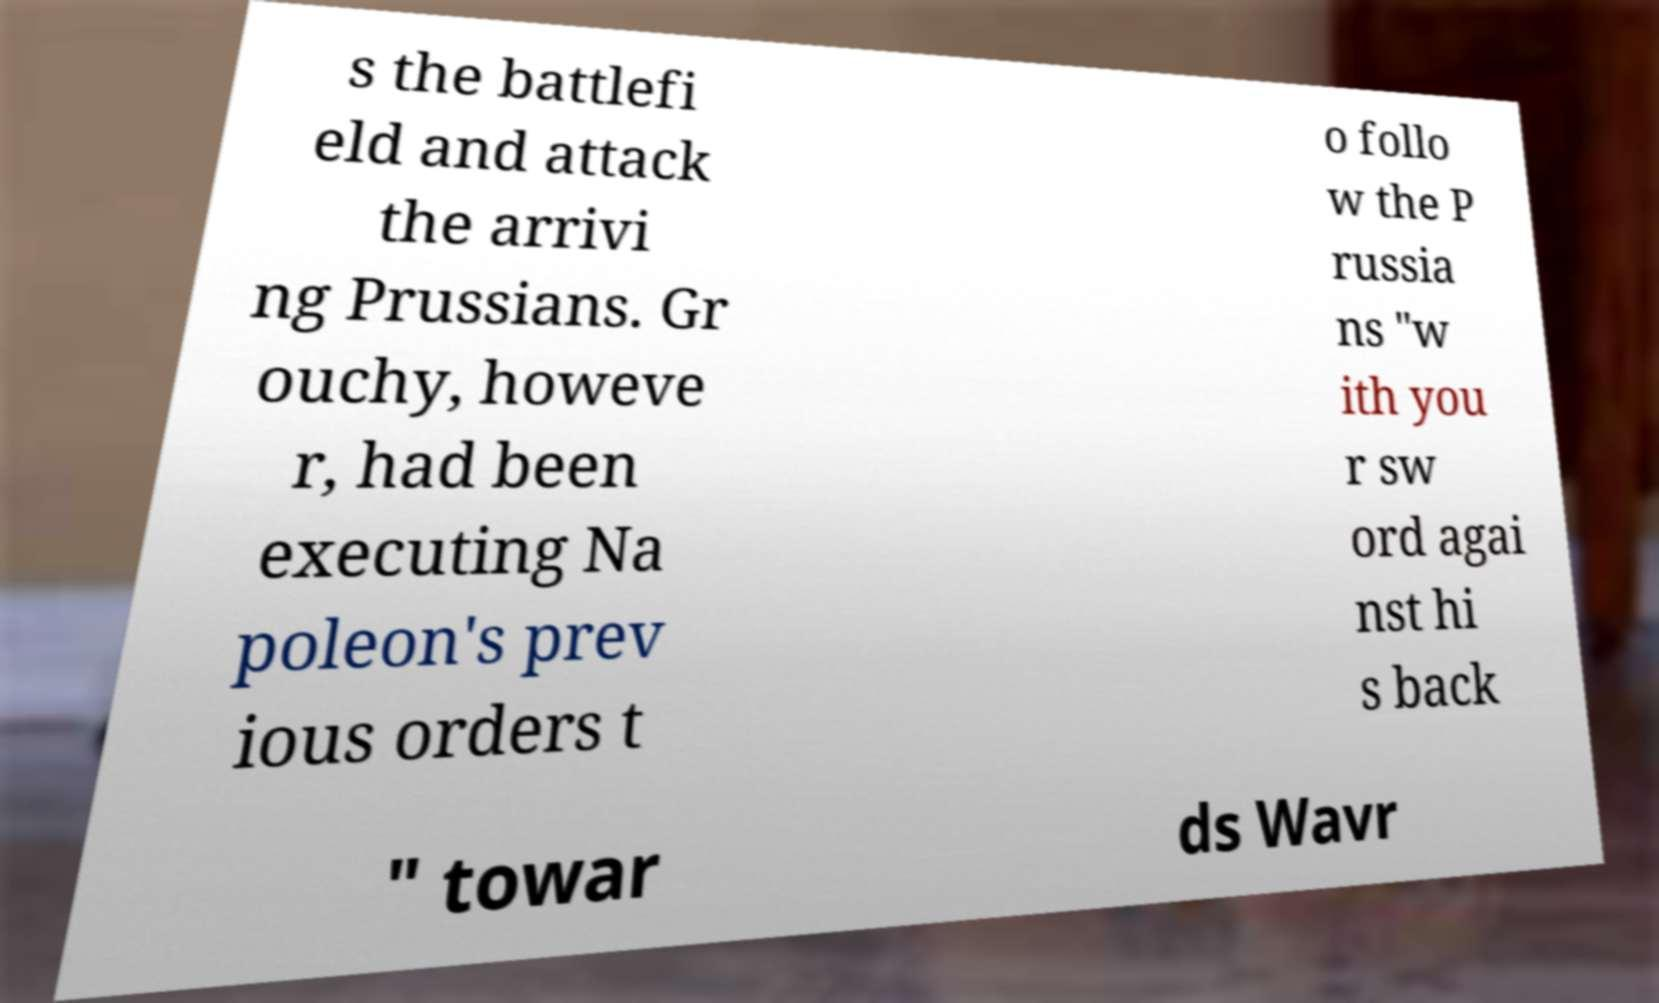I need the written content from this picture converted into text. Can you do that? s the battlefi eld and attack the arrivi ng Prussians. Gr ouchy, howeve r, had been executing Na poleon's prev ious orders t o follo w the P russia ns "w ith you r sw ord agai nst hi s back " towar ds Wavr 